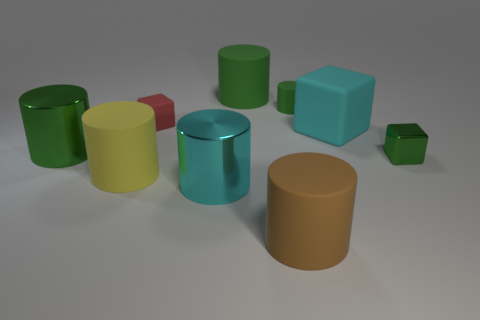Does the tiny shiny object have the same color as the small matte cylinder?
Offer a terse response. Yes. There is a small block on the right side of the tiny green matte cylinder; is its color the same as the small cylinder?
Your answer should be compact. Yes. There is a big matte thing that is the same color as the tiny metal block; what is its shape?
Your answer should be very brief. Cylinder. What size is the yellow matte cylinder?
Offer a very short reply. Large. What color is the matte cube that is the same size as the brown cylinder?
Give a very brief answer. Cyan. Are there any big metal cylinders of the same color as the small metal cube?
Your answer should be compact. Yes. What material is the cyan cylinder?
Your answer should be very brief. Metal. What number of small metal cylinders are there?
Your answer should be very brief. 0. There is a thing on the right side of the large rubber cube; is it the same color as the large shiny thing on the left side of the cyan metal cylinder?
Make the answer very short. Yes. What size is the object that is the same color as the big block?
Your answer should be very brief. Large. 